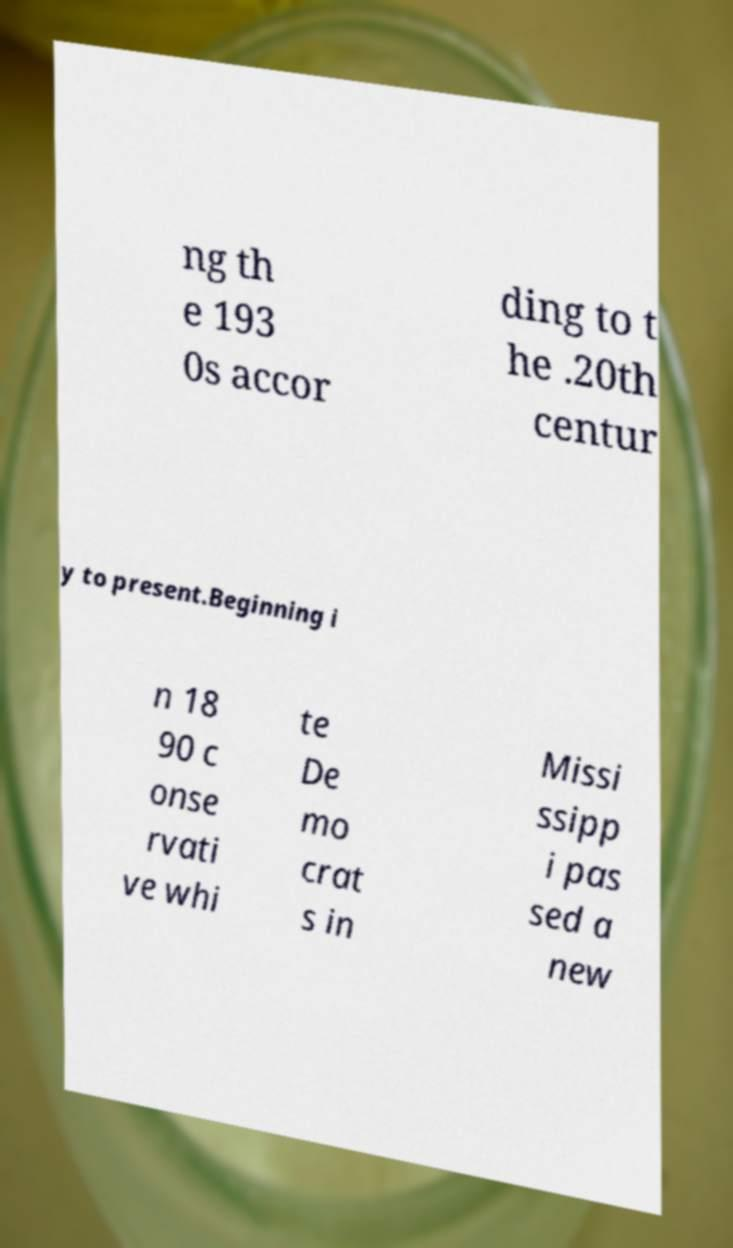What messages or text are displayed in this image? I need them in a readable, typed format. ng th e 193 0s accor ding to t he .20th centur y to present.Beginning i n 18 90 c onse rvati ve whi te De mo crat s in Missi ssipp i pas sed a new 